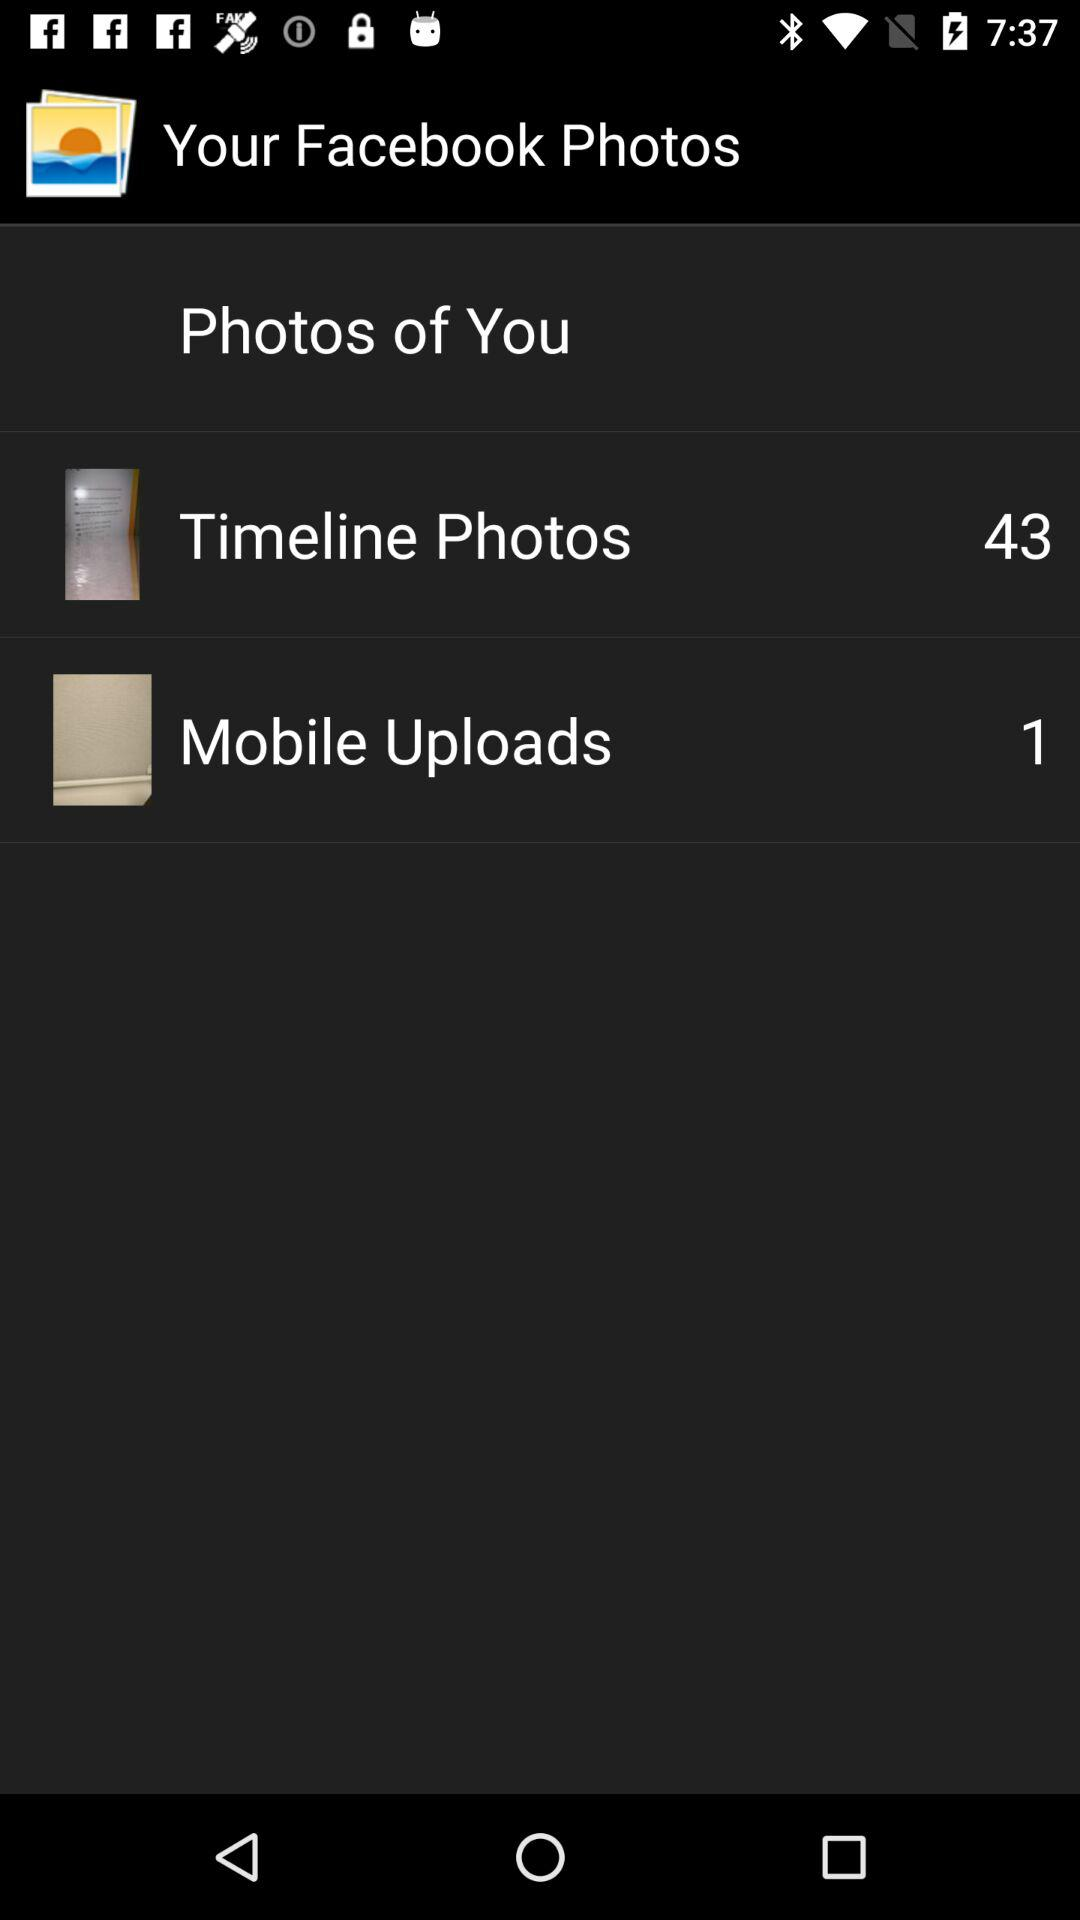Which category has only 1 photo? The category "Mobile Uploads" has 1 photo. 